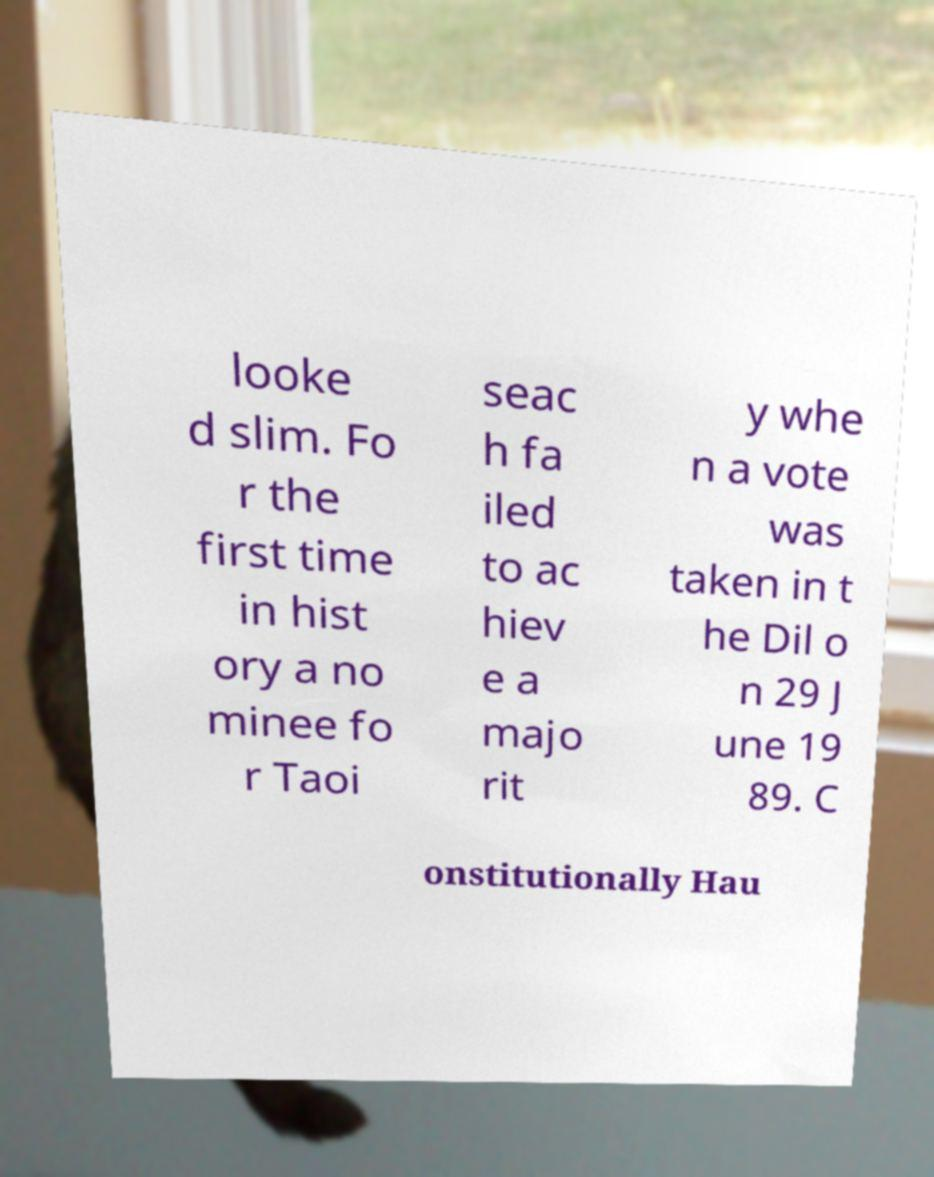Could you assist in decoding the text presented in this image and type it out clearly? looke d slim. Fo r the first time in hist ory a no minee fo r Taoi seac h fa iled to ac hiev e a majo rit y whe n a vote was taken in t he Dil o n 29 J une 19 89. C onstitutionally Hau 